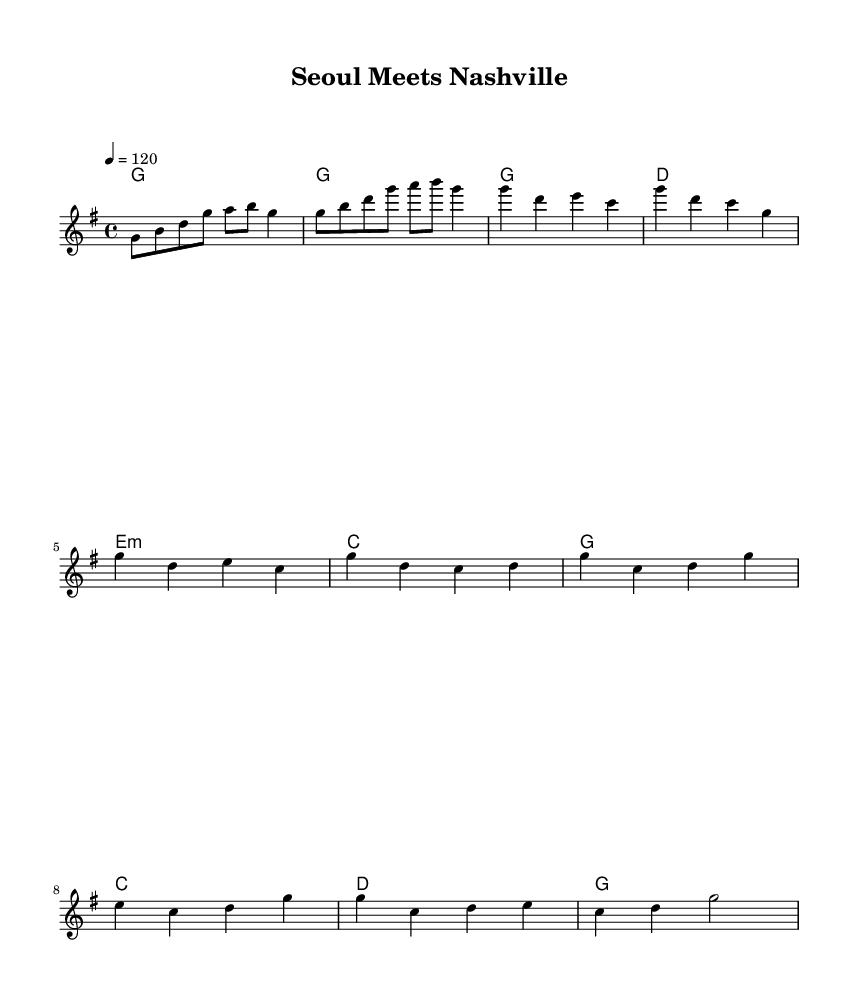What is the key signature of this music? The key signature of the music is G major, which is indicated by one sharp (F#).
Answer: G major What is the time signature of this music? The time signature shown is 4/4, which means there are four beats in each measure.
Answer: 4/4 What is the tempo marking of the piece? The tempo marking indicates a speed of 120 beats per minute, which is typical for pop music.
Answer: 120 How many measures are in the verse section? Counting the measures indicated in the verse, there are four measures from the music shown.
Answer: 4 What is the first chord played in the song? The first chord is shown as G major in the chord names section at the beginning of the piece.
Answer: G How does the harmony change in the chorus compared to the verse? In the chorus, the harmony progresses from G major to C major and D major, while the verse primarily uses G major, D major, E minor, and C major.
Answer: G to C and D What type of musical fusion does this piece represent? The piece demonstrates a fusion of K-Pop and country influences, blending Eastern pop elements with Western chord progressions.
Answer: K-Pop and country fusion 